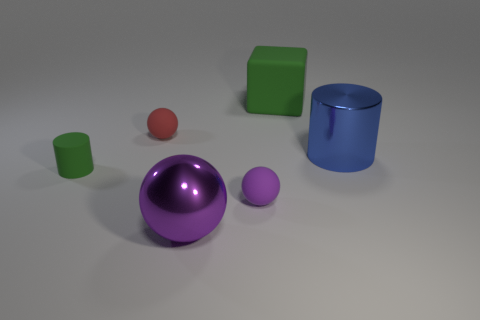Subtract all purple spheres. How many were subtracted if there are1purple spheres left? 1 Subtract all tiny red spheres. How many spheres are left? 2 Subtract all gray cylinders. How many purple balls are left? 2 Add 1 rubber cylinders. How many objects exist? 7 Subtract 2 cylinders. How many cylinders are left? 0 Subtract all purple spheres. How many spheres are left? 1 Subtract all cylinders. How many objects are left? 4 Add 3 red matte spheres. How many red matte spheres are left? 4 Add 3 large matte blocks. How many large matte blocks exist? 4 Subtract 0 blue spheres. How many objects are left? 6 